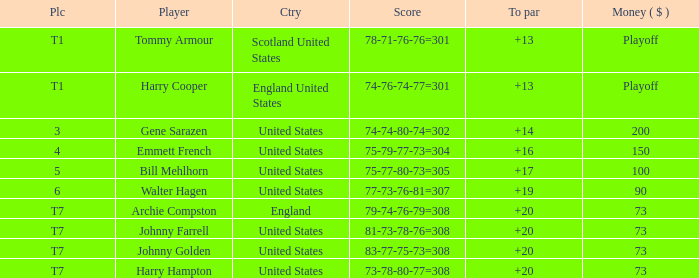What is the ranking when Archie Compston is the player and the money is $73? T7. I'm looking to parse the entire table for insights. Could you assist me with that? {'header': ['Plc', 'Player', 'Ctry', 'Score', 'To par', 'Money ( $ )'], 'rows': [['T1', 'Tommy Armour', 'Scotland United States', '78-71-76-76=301', '+13', 'Playoff'], ['T1', 'Harry Cooper', 'England United States', '74-76-74-77=301', '+13', 'Playoff'], ['3', 'Gene Sarazen', 'United States', '74-74-80-74=302', '+14', '200'], ['4', 'Emmett French', 'United States', '75-79-77-73=304', '+16', '150'], ['5', 'Bill Mehlhorn', 'United States', '75-77-80-73=305', '+17', '100'], ['6', 'Walter Hagen', 'United States', '77-73-76-81=307', '+19', '90'], ['T7', 'Archie Compston', 'England', '79-74-76-79=308', '+20', '73'], ['T7', 'Johnny Farrell', 'United States', '81-73-78-76=308', '+20', '73'], ['T7', 'Johnny Golden', 'United States', '83-77-75-73=308', '+20', '73'], ['T7', 'Harry Hampton', 'United States', '73-78-80-77=308', '+20', '73']]} 